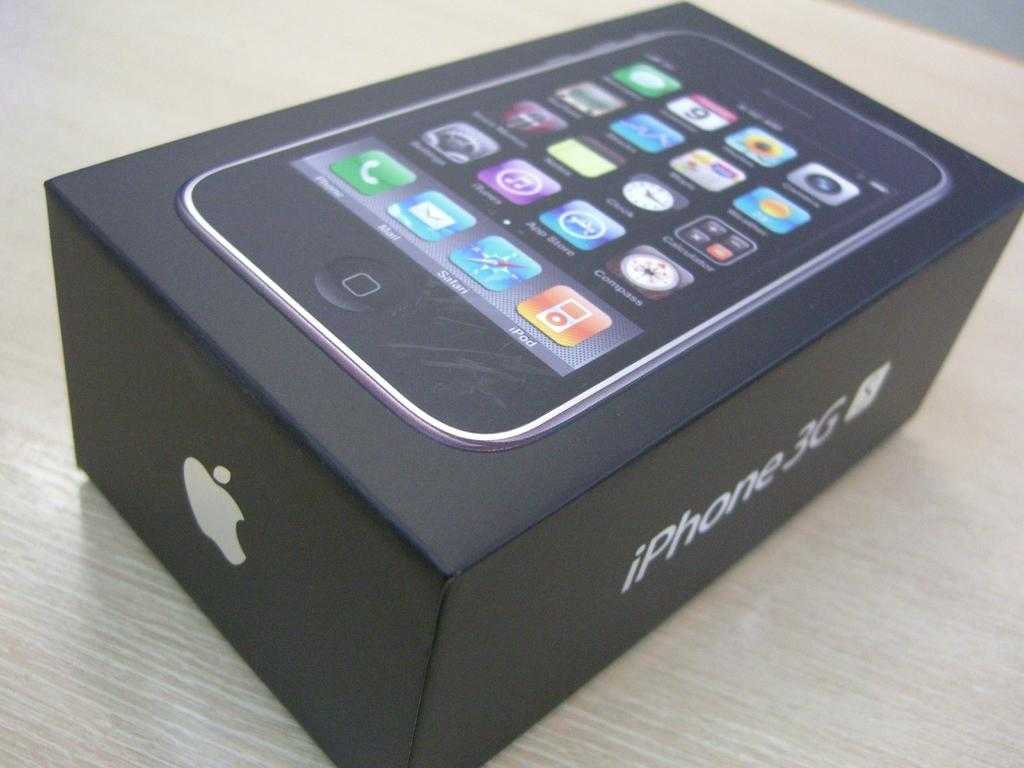<image>
Create a compact narrative representing the image presented. A box for an iphone 3G showing an app page on the top. 